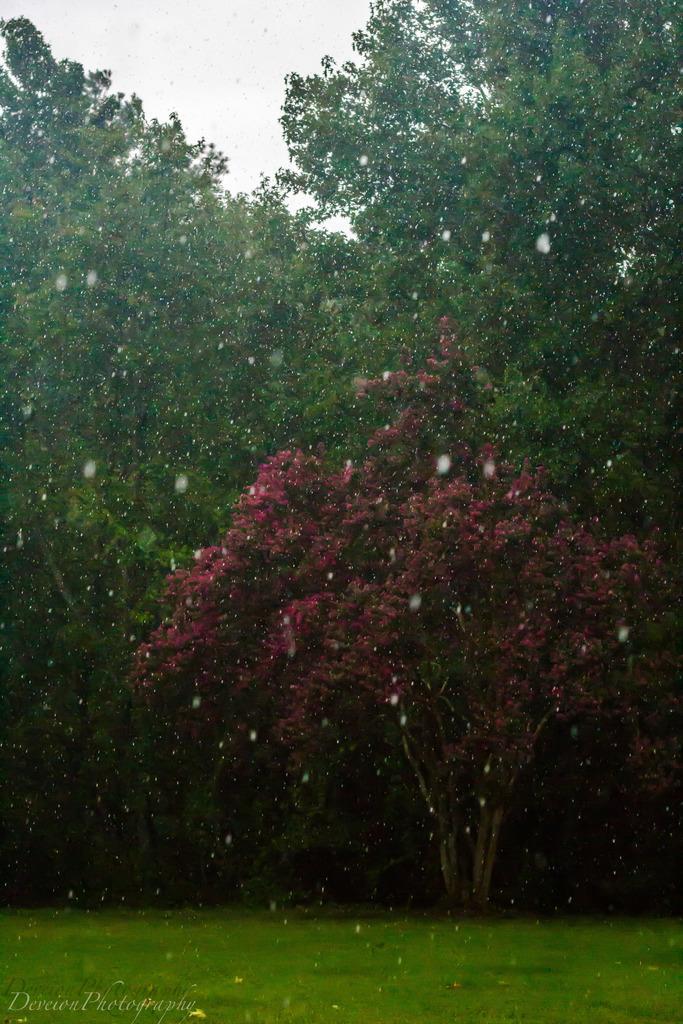In one or two sentences, can you explain what this image depicts? In this picture we can see there are trees, grass and the sky. On the image there is a watermark. 